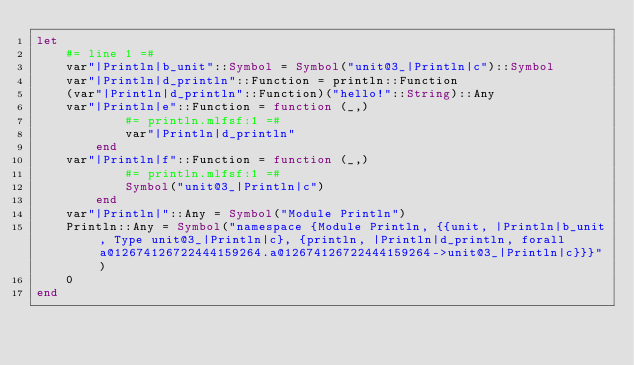<code> <loc_0><loc_0><loc_500><loc_500><_Julia_>let
    #= line 1 =#
    var"|Println|b_unit"::Symbol = Symbol("unit@3_|Println|c")::Symbol
    var"|Println|d_println"::Function = println::Function
    (var"|Println|d_println"::Function)("hello!"::String)::Any
    var"|Println|e"::Function = function (_,)
            #= println.mlfsf:1 =#
            var"|Println|d_println"
        end
    var"|Println|f"::Function = function (_,)
            #= println.mlfsf:1 =#
            Symbol("unit@3_|Println|c")
        end
    var"|Println|"::Any = Symbol("Module Println")
    Println::Any = Symbol("namespace {Module Println, {{unit, |Println|b_unit, Type unit@3_|Println|c}, {println, |Println|d_println, forall a@12674126722444159264.a@12674126722444159264->unit@3_|Println|c}}}")
    0
end
</code> 